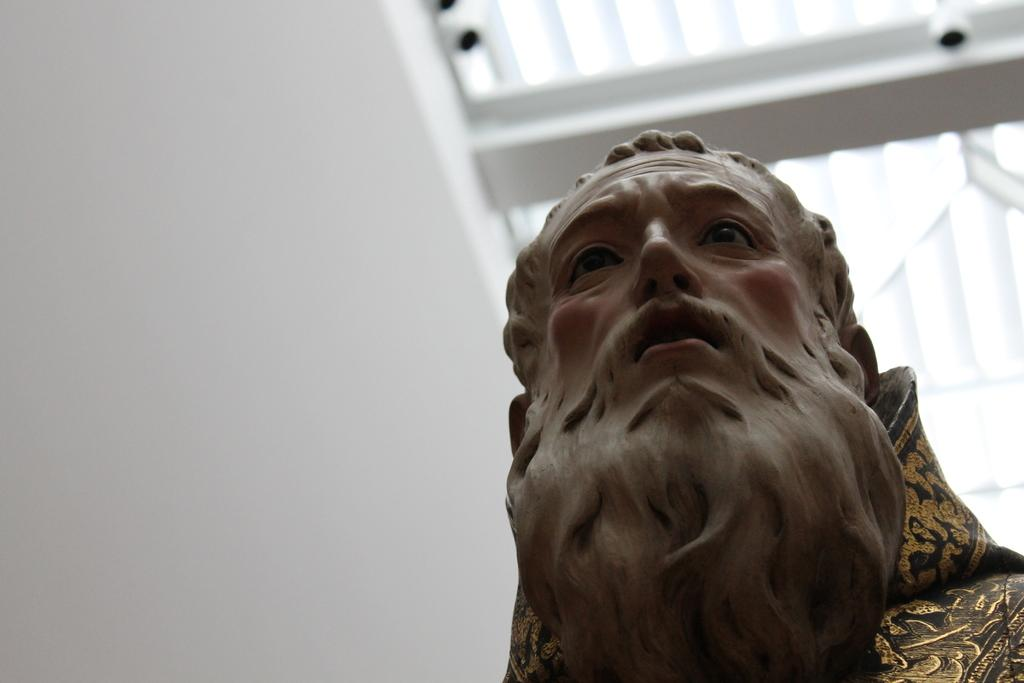What is the main subject of the image? There is a statue of a man in the image. What can be seen on the left side of the image? There is a white wall on the left side of the image. What security feature is visible in the image? CCTV cameras are visible at the top of the image. What type of roof is present in the image? There is a white roof of a building in the image. How many chickens are present in the image? There are no chickens present in the image. What type of bait is being used to attract the statue in the image? The statue is stationary and not attracted by any bait; there is no bait present in the image. 